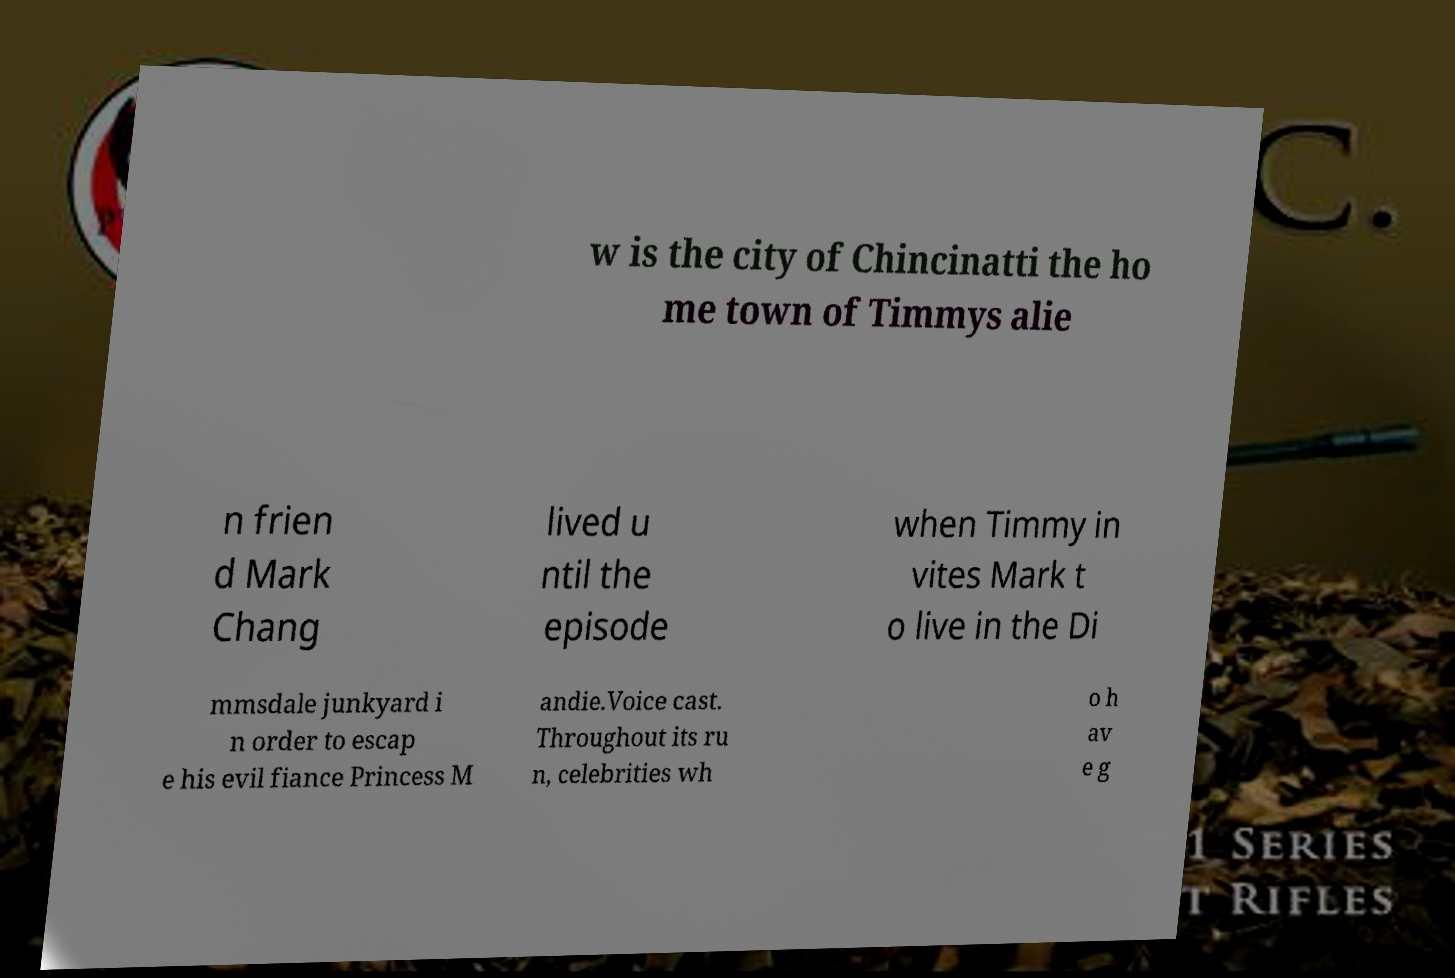Please read and relay the text visible in this image. What does it say? w is the city of Chincinatti the ho me town of Timmys alie n frien d Mark Chang lived u ntil the episode when Timmy in vites Mark t o live in the Di mmsdale junkyard i n order to escap e his evil fiance Princess M andie.Voice cast. Throughout its ru n, celebrities wh o h av e g 